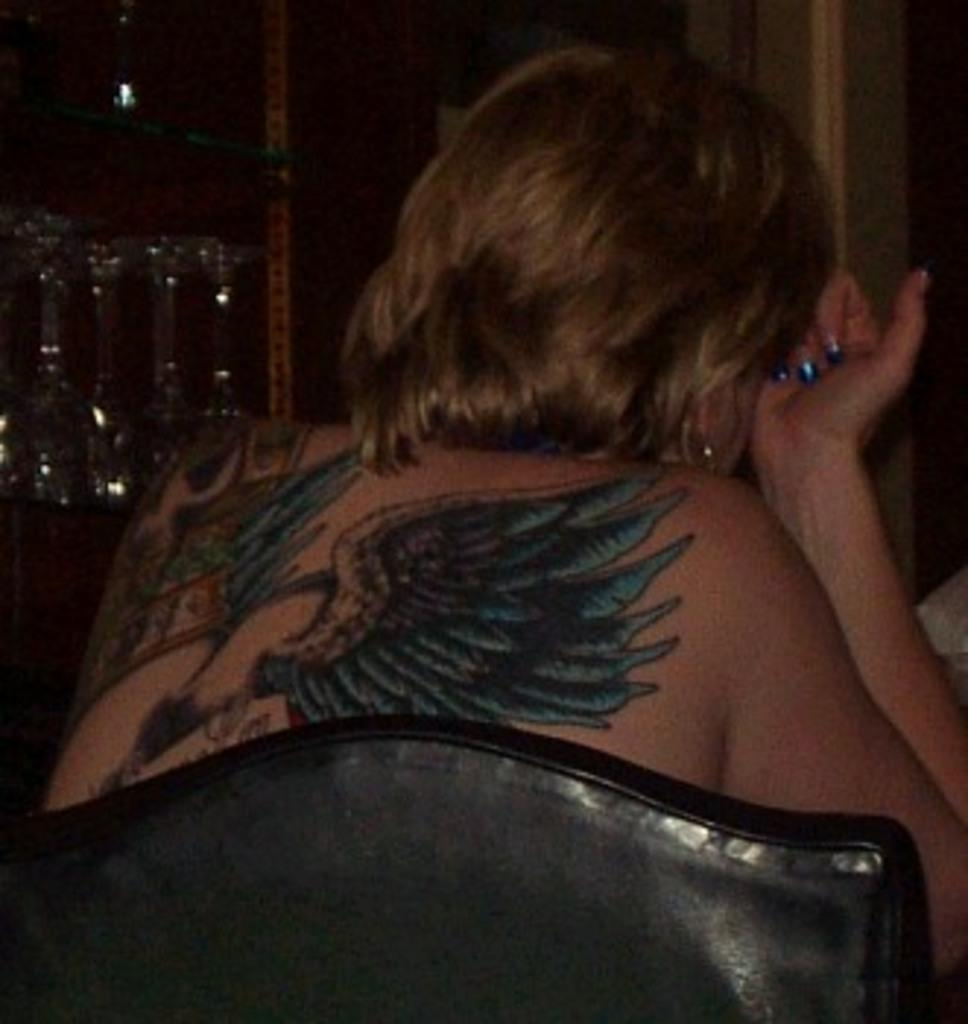What is present in the image? There is a person in the image. Can you describe any specific features of the person? The person has a tattoo on their back. What is the person doing in the image? The person is sitting on a chair. What can be seen in the background of the image? The background of the image is dark, and there are glasses on a shelf. What type of food is being served for lunch in the image? There is no food or mention of lunch in the image; it primarily features a person with a tattoo sitting on a chair. Can you see any icicles hanging from the chair in the image? There are no icicles present in the image. 